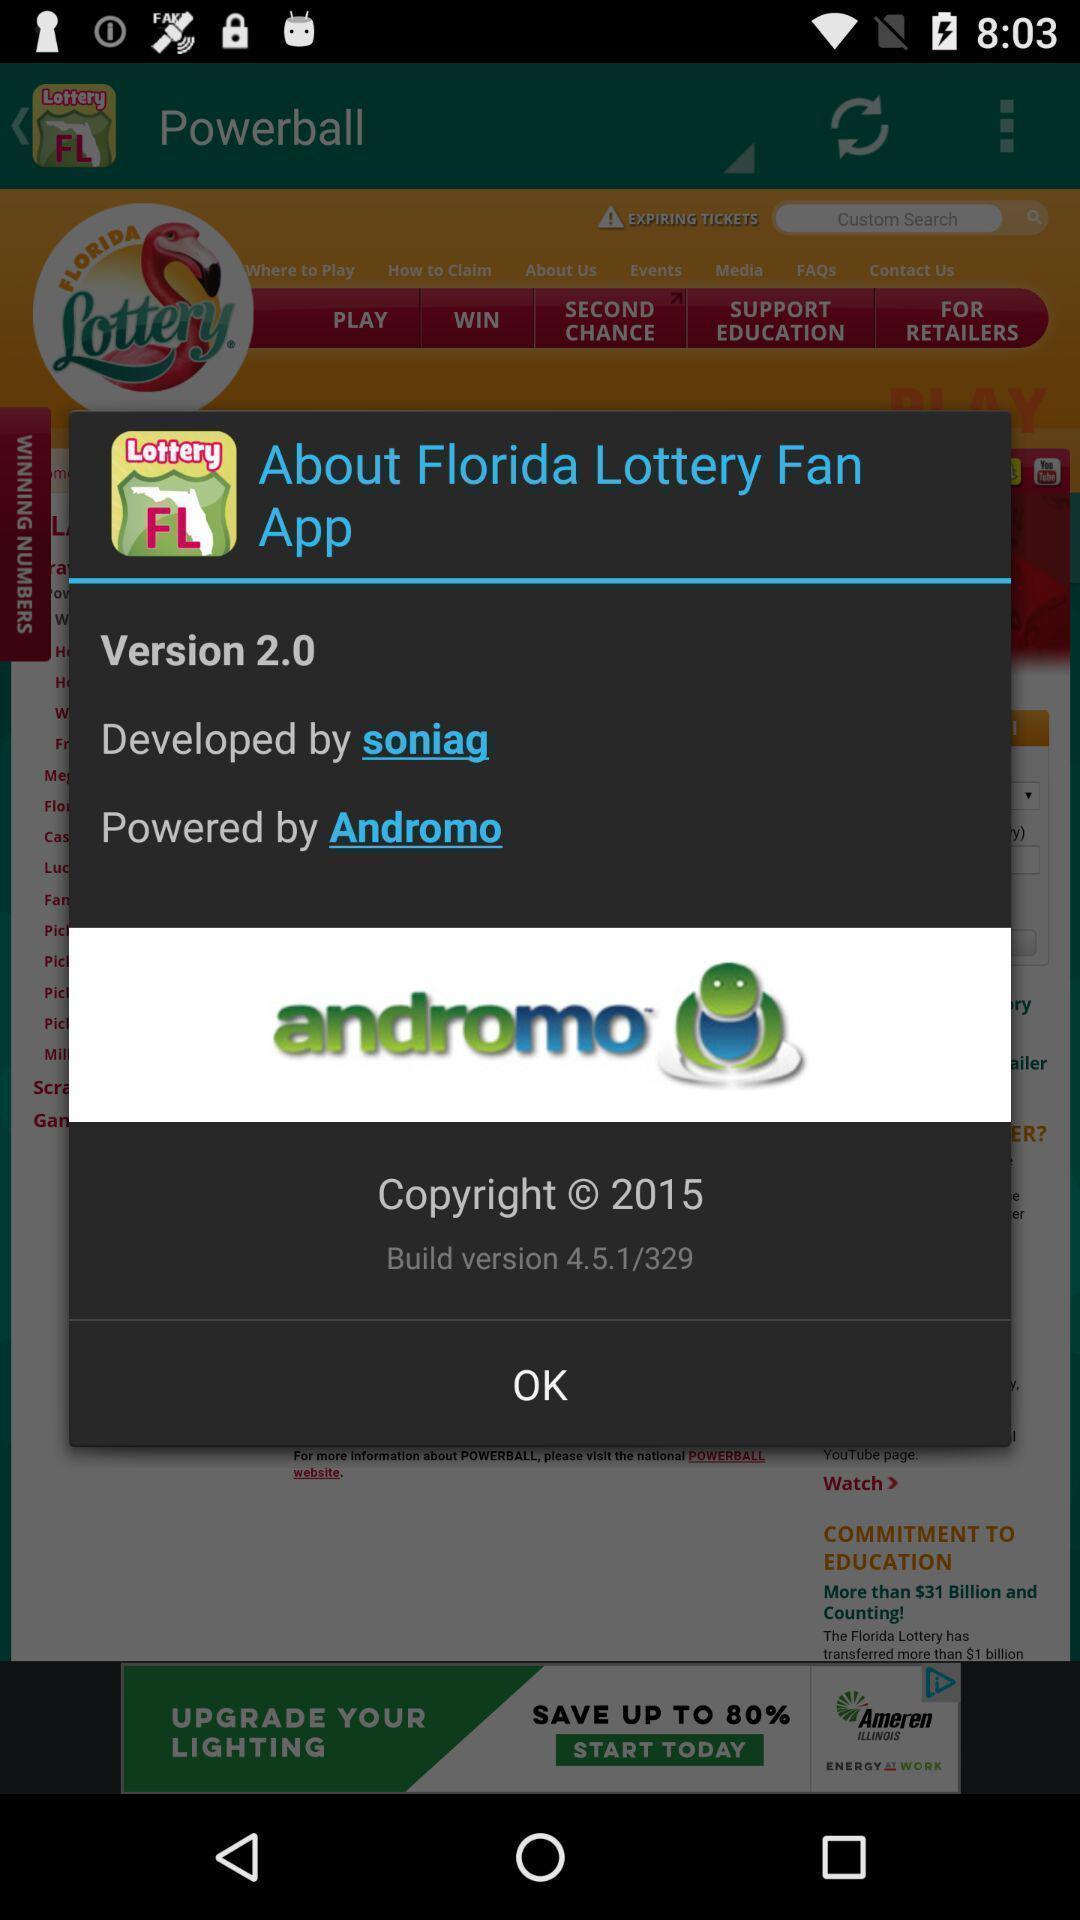Summarize the main components in this picture. Popup for the online lottery app. 